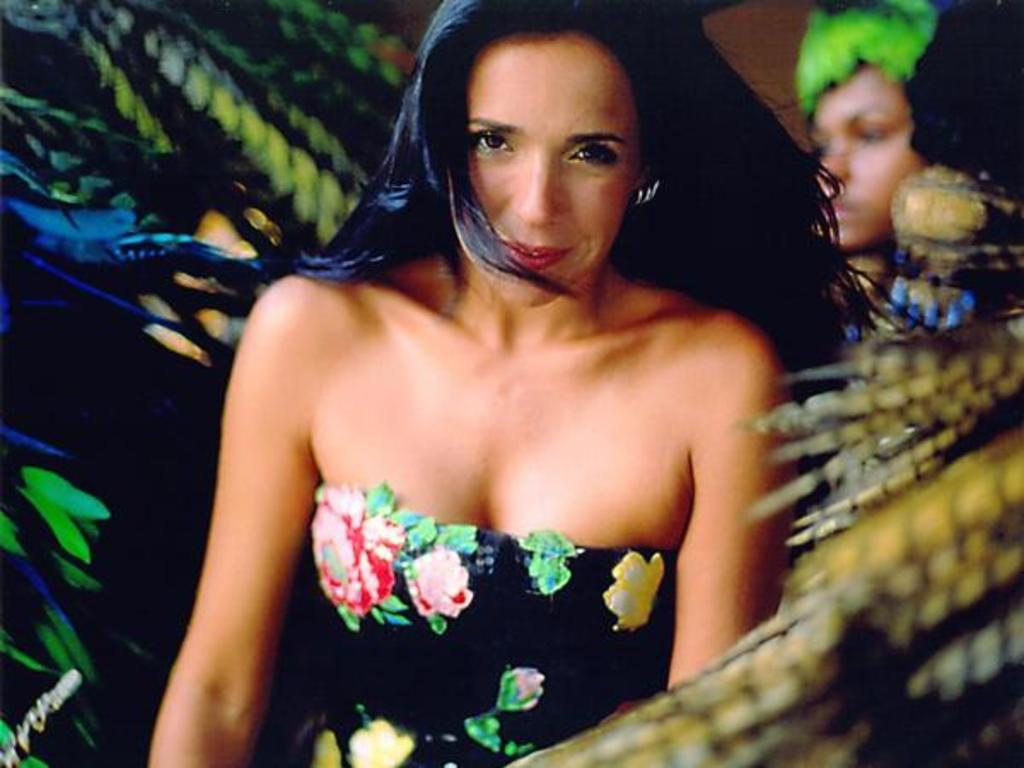Who is the main subject in the image? There is a woman in the center of the image. What part of the woman's face can be seen? The woman's face is visible in the image. What is surrounding the woman in the image? There are feathers around the woman. What type of insurance policy does the woman have in the image? There is no indication of any insurance policy in the image; it only features a woman surrounded by feathers. 